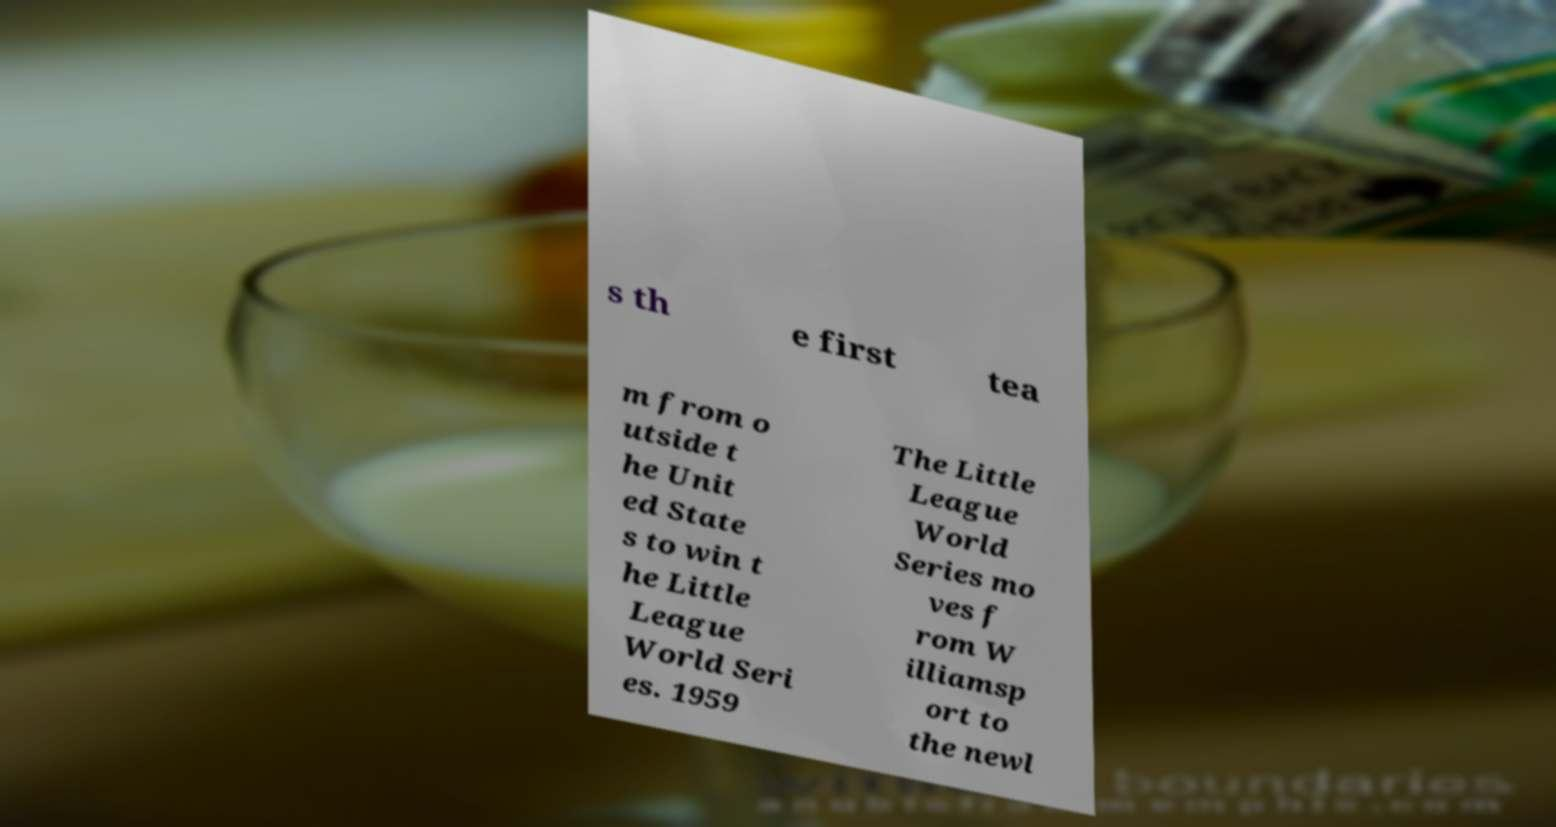Please identify and transcribe the text found in this image. s th e first tea m from o utside t he Unit ed State s to win t he Little League World Seri es. 1959 The Little League World Series mo ves f rom W illiamsp ort to the newl 